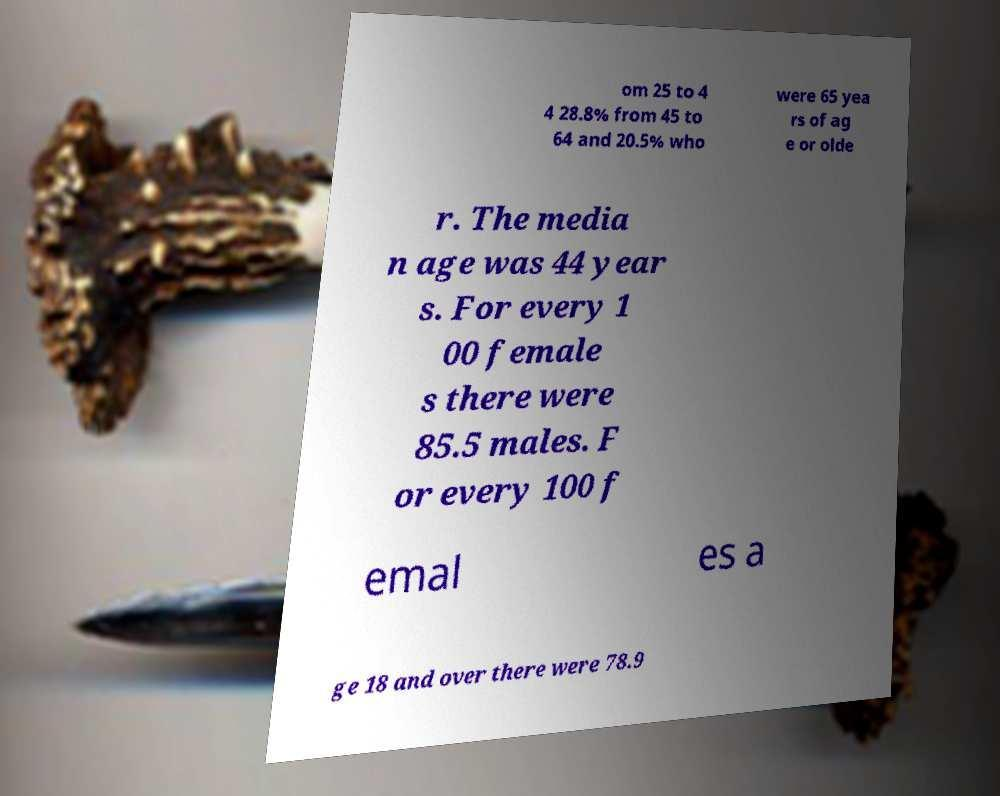Could you assist in decoding the text presented in this image and type it out clearly? om 25 to 4 4 28.8% from 45 to 64 and 20.5% who were 65 yea rs of ag e or olde r. The media n age was 44 year s. For every 1 00 female s there were 85.5 males. F or every 100 f emal es a ge 18 and over there were 78.9 